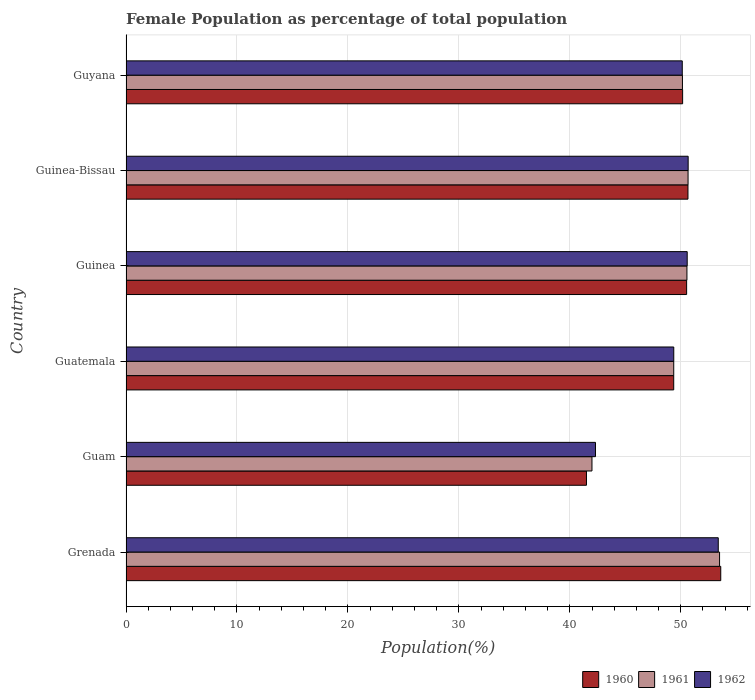How many bars are there on the 1st tick from the top?
Provide a short and direct response. 3. How many bars are there on the 1st tick from the bottom?
Offer a terse response. 3. What is the label of the 4th group of bars from the top?
Give a very brief answer. Guatemala. In how many cases, is the number of bars for a given country not equal to the number of legend labels?
Your response must be concise. 0. What is the female population in in 1962 in Grenada?
Offer a terse response. 53.38. Across all countries, what is the maximum female population in in 1961?
Give a very brief answer. 53.5. Across all countries, what is the minimum female population in in 1960?
Provide a short and direct response. 41.5. In which country was the female population in in 1962 maximum?
Your answer should be very brief. Grenada. In which country was the female population in in 1960 minimum?
Provide a short and direct response. Guam. What is the total female population in in 1961 in the graph?
Ensure brevity in your answer.  296.22. What is the difference between the female population in in 1962 in Grenada and that in Guyana?
Provide a short and direct response. 3.24. What is the difference between the female population in in 1961 in Guyana and the female population in in 1960 in Guinea?
Ensure brevity in your answer.  -0.38. What is the average female population in in 1961 per country?
Keep it short and to the point. 49.37. What is the difference between the female population in in 1961 and female population in in 1960 in Guinea?
Your response must be concise. 0.03. What is the ratio of the female population in in 1962 in Guinea to that in Guinea-Bissau?
Provide a short and direct response. 1. What is the difference between the highest and the second highest female population in in 1961?
Make the answer very short. 2.84. What is the difference between the highest and the lowest female population in in 1962?
Your response must be concise. 11.07. In how many countries, is the female population in in 1960 greater than the average female population in in 1960 taken over all countries?
Offer a terse response. 5. Is it the case that in every country, the sum of the female population in in 1962 and female population in in 1961 is greater than the female population in in 1960?
Ensure brevity in your answer.  Yes. How many bars are there?
Make the answer very short. 18. Are all the bars in the graph horizontal?
Offer a very short reply. Yes. Does the graph contain any zero values?
Give a very brief answer. No. Does the graph contain grids?
Give a very brief answer. Yes. Where does the legend appear in the graph?
Your answer should be compact. Bottom right. How are the legend labels stacked?
Ensure brevity in your answer.  Horizontal. What is the title of the graph?
Provide a short and direct response. Female Population as percentage of total population. Does "1982" appear as one of the legend labels in the graph?
Give a very brief answer. No. What is the label or title of the X-axis?
Your answer should be compact. Population(%). What is the Population(%) of 1960 in Grenada?
Keep it short and to the point. 53.6. What is the Population(%) of 1961 in Grenada?
Provide a succinct answer. 53.5. What is the Population(%) of 1962 in Grenada?
Provide a short and direct response. 53.38. What is the Population(%) of 1960 in Guam?
Provide a succinct answer. 41.5. What is the Population(%) of 1961 in Guam?
Ensure brevity in your answer.  42. What is the Population(%) in 1962 in Guam?
Offer a terse response. 42.31. What is the Population(%) in 1960 in Guatemala?
Your answer should be compact. 49.36. What is the Population(%) of 1961 in Guatemala?
Your answer should be very brief. 49.36. What is the Population(%) in 1962 in Guatemala?
Give a very brief answer. 49.37. What is the Population(%) of 1960 in Guinea?
Provide a short and direct response. 50.53. What is the Population(%) in 1961 in Guinea?
Keep it short and to the point. 50.55. What is the Population(%) of 1962 in Guinea?
Your answer should be very brief. 50.58. What is the Population(%) in 1960 in Guinea-Bissau?
Your response must be concise. 50.65. What is the Population(%) of 1961 in Guinea-Bissau?
Ensure brevity in your answer.  50.66. What is the Population(%) of 1962 in Guinea-Bissau?
Provide a succinct answer. 50.66. What is the Population(%) in 1960 in Guyana?
Your answer should be very brief. 50.17. What is the Population(%) of 1961 in Guyana?
Your answer should be very brief. 50.15. What is the Population(%) in 1962 in Guyana?
Offer a very short reply. 50.13. Across all countries, what is the maximum Population(%) of 1960?
Your response must be concise. 53.6. Across all countries, what is the maximum Population(%) in 1961?
Your answer should be very brief. 53.5. Across all countries, what is the maximum Population(%) of 1962?
Your answer should be compact. 53.38. Across all countries, what is the minimum Population(%) of 1960?
Make the answer very short. 41.5. Across all countries, what is the minimum Population(%) of 1961?
Keep it short and to the point. 42. Across all countries, what is the minimum Population(%) in 1962?
Offer a very short reply. 42.31. What is the total Population(%) of 1960 in the graph?
Your answer should be very brief. 295.81. What is the total Population(%) of 1961 in the graph?
Your answer should be very brief. 296.22. What is the total Population(%) of 1962 in the graph?
Offer a very short reply. 296.44. What is the difference between the Population(%) in 1960 in Grenada and that in Guam?
Give a very brief answer. 12.1. What is the difference between the Population(%) in 1961 in Grenada and that in Guam?
Provide a succinct answer. 11.5. What is the difference between the Population(%) of 1962 in Grenada and that in Guam?
Your answer should be compact. 11.07. What is the difference between the Population(%) of 1960 in Grenada and that in Guatemala?
Offer a terse response. 4.24. What is the difference between the Population(%) of 1961 in Grenada and that in Guatemala?
Ensure brevity in your answer.  4.13. What is the difference between the Population(%) of 1962 in Grenada and that in Guatemala?
Offer a very short reply. 4.01. What is the difference between the Population(%) in 1960 in Grenada and that in Guinea?
Ensure brevity in your answer.  3.08. What is the difference between the Population(%) of 1961 in Grenada and that in Guinea?
Your response must be concise. 2.94. What is the difference between the Population(%) in 1962 in Grenada and that in Guinea?
Your answer should be compact. 2.8. What is the difference between the Population(%) in 1960 in Grenada and that in Guinea-Bissau?
Your answer should be compact. 2.96. What is the difference between the Population(%) in 1961 in Grenada and that in Guinea-Bissau?
Offer a very short reply. 2.84. What is the difference between the Population(%) in 1962 in Grenada and that in Guinea-Bissau?
Keep it short and to the point. 2.71. What is the difference between the Population(%) of 1960 in Grenada and that in Guyana?
Your answer should be compact. 3.44. What is the difference between the Population(%) in 1961 in Grenada and that in Guyana?
Provide a succinct answer. 3.35. What is the difference between the Population(%) of 1962 in Grenada and that in Guyana?
Provide a short and direct response. 3.24. What is the difference between the Population(%) of 1960 in Guam and that in Guatemala?
Offer a terse response. -7.86. What is the difference between the Population(%) of 1961 in Guam and that in Guatemala?
Ensure brevity in your answer.  -7.37. What is the difference between the Population(%) of 1962 in Guam and that in Guatemala?
Provide a succinct answer. -7.06. What is the difference between the Population(%) of 1960 in Guam and that in Guinea?
Make the answer very short. -9.03. What is the difference between the Population(%) in 1961 in Guam and that in Guinea?
Offer a terse response. -8.56. What is the difference between the Population(%) in 1962 in Guam and that in Guinea?
Your answer should be compact. -8.27. What is the difference between the Population(%) in 1960 in Guam and that in Guinea-Bissau?
Provide a short and direct response. -9.15. What is the difference between the Population(%) of 1961 in Guam and that in Guinea-Bissau?
Keep it short and to the point. -8.66. What is the difference between the Population(%) in 1962 in Guam and that in Guinea-Bissau?
Keep it short and to the point. -8.35. What is the difference between the Population(%) in 1960 in Guam and that in Guyana?
Keep it short and to the point. -8.67. What is the difference between the Population(%) of 1961 in Guam and that in Guyana?
Make the answer very short. -8.15. What is the difference between the Population(%) of 1962 in Guam and that in Guyana?
Provide a succinct answer. -7.82. What is the difference between the Population(%) in 1960 in Guatemala and that in Guinea?
Your answer should be compact. -1.16. What is the difference between the Population(%) in 1961 in Guatemala and that in Guinea?
Make the answer very short. -1.19. What is the difference between the Population(%) of 1962 in Guatemala and that in Guinea?
Offer a very short reply. -1.21. What is the difference between the Population(%) of 1960 in Guatemala and that in Guinea-Bissau?
Keep it short and to the point. -1.28. What is the difference between the Population(%) in 1961 in Guatemala and that in Guinea-Bissau?
Your answer should be compact. -1.29. What is the difference between the Population(%) of 1962 in Guatemala and that in Guinea-Bissau?
Make the answer very short. -1.3. What is the difference between the Population(%) in 1960 in Guatemala and that in Guyana?
Your answer should be very brief. -0.8. What is the difference between the Population(%) of 1961 in Guatemala and that in Guyana?
Provide a short and direct response. -0.79. What is the difference between the Population(%) of 1962 in Guatemala and that in Guyana?
Give a very brief answer. -0.77. What is the difference between the Population(%) in 1960 in Guinea and that in Guinea-Bissau?
Give a very brief answer. -0.12. What is the difference between the Population(%) of 1961 in Guinea and that in Guinea-Bissau?
Your response must be concise. -0.1. What is the difference between the Population(%) in 1962 in Guinea and that in Guinea-Bissau?
Ensure brevity in your answer.  -0.09. What is the difference between the Population(%) in 1960 in Guinea and that in Guyana?
Provide a succinct answer. 0.36. What is the difference between the Population(%) of 1961 in Guinea and that in Guyana?
Offer a very short reply. 0.4. What is the difference between the Population(%) in 1962 in Guinea and that in Guyana?
Your response must be concise. 0.45. What is the difference between the Population(%) in 1960 in Guinea-Bissau and that in Guyana?
Your answer should be compact. 0.48. What is the difference between the Population(%) of 1961 in Guinea-Bissau and that in Guyana?
Keep it short and to the point. 0.51. What is the difference between the Population(%) in 1962 in Guinea-Bissau and that in Guyana?
Make the answer very short. 0.53. What is the difference between the Population(%) in 1960 in Grenada and the Population(%) in 1961 in Guam?
Keep it short and to the point. 11.61. What is the difference between the Population(%) in 1960 in Grenada and the Population(%) in 1962 in Guam?
Make the answer very short. 11.29. What is the difference between the Population(%) in 1961 in Grenada and the Population(%) in 1962 in Guam?
Ensure brevity in your answer.  11.18. What is the difference between the Population(%) of 1960 in Grenada and the Population(%) of 1961 in Guatemala?
Offer a very short reply. 4.24. What is the difference between the Population(%) of 1960 in Grenada and the Population(%) of 1962 in Guatemala?
Your answer should be compact. 4.23. What is the difference between the Population(%) in 1961 in Grenada and the Population(%) in 1962 in Guatemala?
Your answer should be compact. 4.13. What is the difference between the Population(%) in 1960 in Grenada and the Population(%) in 1961 in Guinea?
Your response must be concise. 3.05. What is the difference between the Population(%) in 1960 in Grenada and the Population(%) in 1962 in Guinea?
Offer a terse response. 3.02. What is the difference between the Population(%) of 1961 in Grenada and the Population(%) of 1962 in Guinea?
Your answer should be compact. 2.92. What is the difference between the Population(%) in 1960 in Grenada and the Population(%) in 1961 in Guinea-Bissau?
Provide a short and direct response. 2.95. What is the difference between the Population(%) in 1960 in Grenada and the Population(%) in 1962 in Guinea-Bissau?
Make the answer very short. 2.94. What is the difference between the Population(%) in 1961 in Grenada and the Population(%) in 1962 in Guinea-Bissau?
Make the answer very short. 2.83. What is the difference between the Population(%) in 1960 in Grenada and the Population(%) in 1961 in Guyana?
Ensure brevity in your answer.  3.45. What is the difference between the Population(%) in 1960 in Grenada and the Population(%) in 1962 in Guyana?
Your answer should be very brief. 3.47. What is the difference between the Population(%) in 1961 in Grenada and the Population(%) in 1962 in Guyana?
Your answer should be very brief. 3.36. What is the difference between the Population(%) in 1960 in Guam and the Population(%) in 1961 in Guatemala?
Offer a very short reply. -7.87. What is the difference between the Population(%) of 1960 in Guam and the Population(%) of 1962 in Guatemala?
Keep it short and to the point. -7.87. What is the difference between the Population(%) in 1961 in Guam and the Population(%) in 1962 in Guatemala?
Ensure brevity in your answer.  -7.37. What is the difference between the Population(%) in 1960 in Guam and the Population(%) in 1961 in Guinea?
Offer a very short reply. -9.06. What is the difference between the Population(%) in 1960 in Guam and the Population(%) in 1962 in Guinea?
Your answer should be compact. -9.08. What is the difference between the Population(%) of 1961 in Guam and the Population(%) of 1962 in Guinea?
Your answer should be compact. -8.58. What is the difference between the Population(%) in 1960 in Guam and the Population(%) in 1961 in Guinea-Bissau?
Offer a terse response. -9.16. What is the difference between the Population(%) of 1960 in Guam and the Population(%) of 1962 in Guinea-Bissau?
Offer a terse response. -9.17. What is the difference between the Population(%) in 1961 in Guam and the Population(%) in 1962 in Guinea-Bissau?
Make the answer very short. -8.67. What is the difference between the Population(%) in 1960 in Guam and the Population(%) in 1961 in Guyana?
Your answer should be very brief. -8.65. What is the difference between the Population(%) of 1960 in Guam and the Population(%) of 1962 in Guyana?
Offer a terse response. -8.63. What is the difference between the Population(%) of 1961 in Guam and the Population(%) of 1962 in Guyana?
Your answer should be very brief. -8.14. What is the difference between the Population(%) of 1960 in Guatemala and the Population(%) of 1961 in Guinea?
Ensure brevity in your answer.  -1.19. What is the difference between the Population(%) of 1960 in Guatemala and the Population(%) of 1962 in Guinea?
Your answer should be compact. -1.22. What is the difference between the Population(%) of 1961 in Guatemala and the Population(%) of 1962 in Guinea?
Provide a short and direct response. -1.21. What is the difference between the Population(%) of 1960 in Guatemala and the Population(%) of 1961 in Guinea-Bissau?
Your answer should be very brief. -1.29. What is the difference between the Population(%) of 1960 in Guatemala and the Population(%) of 1962 in Guinea-Bissau?
Make the answer very short. -1.3. What is the difference between the Population(%) in 1961 in Guatemala and the Population(%) in 1962 in Guinea-Bissau?
Make the answer very short. -1.3. What is the difference between the Population(%) in 1960 in Guatemala and the Population(%) in 1961 in Guyana?
Your answer should be very brief. -0.79. What is the difference between the Population(%) of 1960 in Guatemala and the Population(%) of 1962 in Guyana?
Your answer should be very brief. -0.77. What is the difference between the Population(%) of 1961 in Guatemala and the Population(%) of 1962 in Guyana?
Your answer should be compact. -0.77. What is the difference between the Population(%) in 1960 in Guinea and the Population(%) in 1961 in Guinea-Bissau?
Your answer should be compact. -0.13. What is the difference between the Population(%) of 1960 in Guinea and the Population(%) of 1962 in Guinea-Bissau?
Offer a terse response. -0.14. What is the difference between the Population(%) of 1961 in Guinea and the Population(%) of 1962 in Guinea-Bissau?
Your response must be concise. -0.11. What is the difference between the Population(%) of 1960 in Guinea and the Population(%) of 1961 in Guyana?
Make the answer very short. 0.38. What is the difference between the Population(%) in 1960 in Guinea and the Population(%) in 1962 in Guyana?
Offer a terse response. 0.39. What is the difference between the Population(%) of 1961 in Guinea and the Population(%) of 1962 in Guyana?
Your answer should be very brief. 0.42. What is the difference between the Population(%) in 1960 in Guinea-Bissau and the Population(%) in 1961 in Guyana?
Offer a very short reply. 0.5. What is the difference between the Population(%) in 1960 in Guinea-Bissau and the Population(%) in 1962 in Guyana?
Provide a short and direct response. 0.51. What is the difference between the Population(%) of 1961 in Guinea-Bissau and the Population(%) of 1962 in Guyana?
Make the answer very short. 0.52. What is the average Population(%) of 1960 per country?
Offer a terse response. 49.3. What is the average Population(%) in 1961 per country?
Offer a terse response. 49.37. What is the average Population(%) in 1962 per country?
Ensure brevity in your answer.  49.41. What is the difference between the Population(%) of 1960 and Population(%) of 1961 in Grenada?
Your answer should be compact. 0.11. What is the difference between the Population(%) in 1960 and Population(%) in 1962 in Grenada?
Provide a short and direct response. 0.22. What is the difference between the Population(%) of 1961 and Population(%) of 1962 in Grenada?
Offer a very short reply. 0.12. What is the difference between the Population(%) of 1960 and Population(%) of 1961 in Guam?
Keep it short and to the point. -0.5. What is the difference between the Population(%) in 1960 and Population(%) in 1962 in Guam?
Your answer should be very brief. -0.81. What is the difference between the Population(%) of 1961 and Population(%) of 1962 in Guam?
Keep it short and to the point. -0.32. What is the difference between the Population(%) of 1960 and Population(%) of 1961 in Guatemala?
Provide a succinct answer. -0. What is the difference between the Population(%) of 1960 and Population(%) of 1962 in Guatemala?
Provide a succinct answer. -0. What is the difference between the Population(%) of 1961 and Population(%) of 1962 in Guatemala?
Your response must be concise. -0. What is the difference between the Population(%) in 1960 and Population(%) in 1961 in Guinea?
Your response must be concise. -0.03. What is the difference between the Population(%) in 1960 and Population(%) in 1962 in Guinea?
Your answer should be compact. -0.05. What is the difference between the Population(%) in 1961 and Population(%) in 1962 in Guinea?
Offer a very short reply. -0.02. What is the difference between the Population(%) of 1960 and Population(%) of 1961 in Guinea-Bissau?
Offer a terse response. -0.01. What is the difference between the Population(%) in 1960 and Population(%) in 1962 in Guinea-Bissau?
Make the answer very short. -0.02. What is the difference between the Population(%) of 1961 and Population(%) of 1962 in Guinea-Bissau?
Your answer should be very brief. -0.01. What is the difference between the Population(%) of 1960 and Population(%) of 1961 in Guyana?
Your answer should be very brief. 0.02. What is the difference between the Population(%) of 1960 and Population(%) of 1962 in Guyana?
Your answer should be compact. 0.03. What is the difference between the Population(%) of 1961 and Population(%) of 1962 in Guyana?
Provide a succinct answer. 0.02. What is the ratio of the Population(%) in 1960 in Grenada to that in Guam?
Keep it short and to the point. 1.29. What is the ratio of the Population(%) in 1961 in Grenada to that in Guam?
Provide a short and direct response. 1.27. What is the ratio of the Population(%) in 1962 in Grenada to that in Guam?
Give a very brief answer. 1.26. What is the ratio of the Population(%) in 1960 in Grenada to that in Guatemala?
Your answer should be very brief. 1.09. What is the ratio of the Population(%) in 1961 in Grenada to that in Guatemala?
Ensure brevity in your answer.  1.08. What is the ratio of the Population(%) in 1962 in Grenada to that in Guatemala?
Keep it short and to the point. 1.08. What is the ratio of the Population(%) of 1960 in Grenada to that in Guinea?
Offer a terse response. 1.06. What is the ratio of the Population(%) of 1961 in Grenada to that in Guinea?
Offer a terse response. 1.06. What is the ratio of the Population(%) in 1962 in Grenada to that in Guinea?
Your answer should be compact. 1.06. What is the ratio of the Population(%) in 1960 in Grenada to that in Guinea-Bissau?
Provide a short and direct response. 1.06. What is the ratio of the Population(%) in 1961 in Grenada to that in Guinea-Bissau?
Your response must be concise. 1.06. What is the ratio of the Population(%) of 1962 in Grenada to that in Guinea-Bissau?
Make the answer very short. 1.05. What is the ratio of the Population(%) in 1960 in Grenada to that in Guyana?
Give a very brief answer. 1.07. What is the ratio of the Population(%) of 1961 in Grenada to that in Guyana?
Provide a succinct answer. 1.07. What is the ratio of the Population(%) of 1962 in Grenada to that in Guyana?
Offer a very short reply. 1.06. What is the ratio of the Population(%) in 1960 in Guam to that in Guatemala?
Your answer should be very brief. 0.84. What is the ratio of the Population(%) of 1961 in Guam to that in Guatemala?
Your answer should be very brief. 0.85. What is the ratio of the Population(%) in 1960 in Guam to that in Guinea?
Keep it short and to the point. 0.82. What is the ratio of the Population(%) of 1961 in Guam to that in Guinea?
Provide a succinct answer. 0.83. What is the ratio of the Population(%) in 1962 in Guam to that in Guinea?
Ensure brevity in your answer.  0.84. What is the ratio of the Population(%) in 1960 in Guam to that in Guinea-Bissau?
Make the answer very short. 0.82. What is the ratio of the Population(%) of 1961 in Guam to that in Guinea-Bissau?
Keep it short and to the point. 0.83. What is the ratio of the Population(%) of 1962 in Guam to that in Guinea-Bissau?
Keep it short and to the point. 0.84. What is the ratio of the Population(%) in 1960 in Guam to that in Guyana?
Make the answer very short. 0.83. What is the ratio of the Population(%) in 1961 in Guam to that in Guyana?
Your response must be concise. 0.84. What is the ratio of the Population(%) of 1962 in Guam to that in Guyana?
Give a very brief answer. 0.84. What is the ratio of the Population(%) in 1961 in Guatemala to that in Guinea?
Offer a very short reply. 0.98. What is the ratio of the Population(%) of 1962 in Guatemala to that in Guinea?
Give a very brief answer. 0.98. What is the ratio of the Population(%) of 1960 in Guatemala to that in Guinea-Bissau?
Your response must be concise. 0.97. What is the ratio of the Population(%) of 1961 in Guatemala to that in Guinea-Bissau?
Offer a terse response. 0.97. What is the ratio of the Population(%) of 1962 in Guatemala to that in Guinea-Bissau?
Your response must be concise. 0.97. What is the ratio of the Population(%) of 1961 in Guatemala to that in Guyana?
Provide a short and direct response. 0.98. What is the ratio of the Population(%) of 1962 in Guatemala to that in Guyana?
Your response must be concise. 0.98. What is the ratio of the Population(%) of 1961 in Guinea to that in Guinea-Bissau?
Your answer should be very brief. 1. What is the ratio of the Population(%) in 1962 in Guinea to that in Guinea-Bissau?
Provide a short and direct response. 1. What is the ratio of the Population(%) of 1960 in Guinea to that in Guyana?
Your answer should be compact. 1.01. What is the ratio of the Population(%) of 1961 in Guinea to that in Guyana?
Your response must be concise. 1.01. What is the ratio of the Population(%) in 1962 in Guinea to that in Guyana?
Keep it short and to the point. 1.01. What is the ratio of the Population(%) of 1960 in Guinea-Bissau to that in Guyana?
Keep it short and to the point. 1.01. What is the ratio of the Population(%) in 1961 in Guinea-Bissau to that in Guyana?
Keep it short and to the point. 1.01. What is the ratio of the Population(%) in 1962 in Guinea-Bissau to that in Guyana?
Your answer should be very brief. 1.01. What is the difference between the highest and the second highest Population(%) of 1960?
Provide a succinct answer. 2.96. What is the difference between the highest and the second highest Population(%) of 1961?
Make the answer very short. 2.84. What is the difference between the highest and the second highest Population(%) in 1962?
Give a very brief answer. 2.71. What is the difference between the highest and the lowest Population(%) in 1960?
Ensure brevity in your answer.  12.1. What is the difference between the highest and the lowest Population(%) of 1961?
Offer a terse response. 11.5. What is the difference between the highest and the lowest Population(%) in 1962?
Keep it short and to the point. 11.07. 